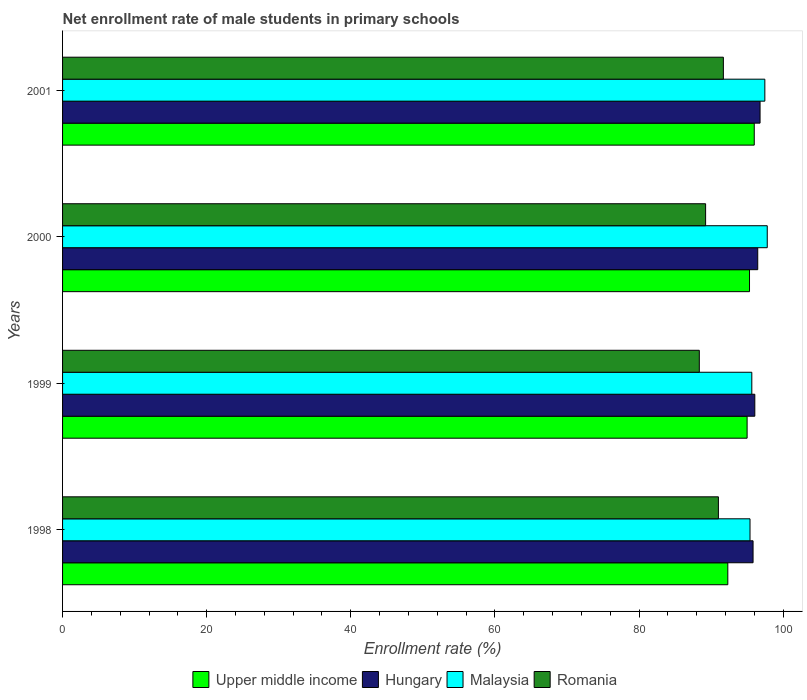How many different coloured bars are there?
Make the answer very short. 4. How many groups of bars are there?
Your response must be concise. 4. How many bars are there on the 1st tick from the top?
Your answer should be compact. 4. What is the net enrollment rate of male students in primary schools in Hungary in 1998?
Offer a very short reply. 95.83. Across all years, what is the maximum net enrollment rate of male students in primary schools in Romania?
Give a very brief answer. 91.71. Across all years, what is the minimum net enrollment rate of male students in primary schools in Upper middle income?
Make the answer very short. 92.32. In which year was the net enrollment rate of male students in primary schools in Hungary minimum?
Your answer should be very brief. 1998. What is the total net enrollment rate of male students in primary schools in Romania in the graph?
Make the answer very short. 360.34. What is the difference between the net enrollment rate of male students in primary schools in Romania in 2000 and that in 2001?
Offer a terse response. -2.47. What is the difference between the net enrollment rate of male students in primary schools in Romania in 2000 and the net enrollment rate of male students in primary schools in Hungary in 1999?
Your response must be concise. -6.83. What is the average net enrollment rate of male students in primary schools in Romania per year?
Give a very brief answer. 90.08. In the year 1999, what is the difference between the net enrollment rate of male students in primary schools in Upper middle income and net enrollment rate of male students in primary schools in Romania?
Your answer should be compact. 6.63. What is the ratio of the net enrollment rate of male students in primary schools in Hungary in 2000 to that in 2001?
Provide a succinct answer. 1. Is the net enrollment rate of male students in primary schools in Romania in 1998 less than that in 2000?
Provide a short and direct response. No. What is the difference between the highest and the second highest net enrollment rate of male students in primary schools in Romania?
Give a very brief answer. 0.69. What is the difference between the highest and the lowest net enrollment rate of male students in primary schools in Hungary?
Your response must be concise. 0.97. Is the sum of the net enrollment rate of male students in primary schools in Upper middle income in 2000 and 2001 greater than the maximum net enrollment rate of male students in primary schools in Hungary across all years?
Make the answer very short. Yes. Is it the case that in every year, the sum of the net enrollment rate of male students in primary schools in Malaysia and net enrollment rate of male students in primary schools in Hungary is greater than the sum of net enrollment rate of male students in primary schools in Romania and net enrollment rate of male students in primary schools in Upper middle income?
Provide a succinct answer. Yes. What does the 4th bar from the top in 1999 represents?
Offer a very short reply. Upper middle income. What does the 2nd bar from the bottom in 2000 represents?
Your answer should be very brief. Hungary. How many bars are there?
Provide a succinct answer. 16. Are all the bars in the graph horizontal?
Keep it short and to the point. Yes. What is the difference between two consecutive major ticks on the X-axis?
Give a very brief answer. 20. Are the values on the major ticks of X-axis written in scientific E-notation?
Offer a terse response. No. Does the graph contain grids?
Give a very brief answer. No. How many legend labels are there?
Keep it short and to the point. 4. How are the legend labels stacked?
Ensure brevity in your answer.  Horizontal. What is the title of the graph?
Offer a very short reply. Net enrollment rate of male students in primary schools. What is the label or title of the X-axis?
Give a very brief answer. Enrollment rate (%). What is the Enrollment rate (%) of Upper middle income in 1998?
Offer a terse response. 92.32. What is the Enrollment rate (%) in Hungary in 1998?
Provide a succinct answer. 95.83. What is the Enrollment rate (%) of Malaysia in 1998?
Your answer should be compact. 95.4. What is the Enrollment rate (%) in Romania in 1998?
Offer a very short reply. 91.02. What is the Enrollment rate (%) of Upper middle income in 1999?
Your response must be concise. 95. What is the Enrollment rate (%) in Hungary in 1999?
Give a very brief answer. 96.07. What is the Enrollment rate (%) of Malaysia in 1999?
Make the answer very short. 95.65. What is the Enrollment rate (%) in Romania in 1999?
Provide a succinct answer. 88.37. What is the Enrollment rate (%) of Upper middle income in 2000?
Offer a very short reply. 95.33. What is the Enrollment rate (%) of Hungary in 2000?
Offer a very short reply. 96.48. What is the Enrollment rate (%) of Malaysia in 2000?
Keep it short and to the point. 97.8. What is the Enrollment rate (%) of Romania in 2000?
Provide a short and direct response. 89.24. What is the Enrollment rate (%) in Upper middle income in 2001?
Your answer should be very brief. 95.99. What is the Enrollment rate (%) of Hungary in 2001?
Your answer should be very brief. 96.8. What is the Enrollment rate (%) of Malaysia in 2001?
Ensure brevity in your answer.  97.46. What is the Enrollment rate (%) in Romania in 2001?
Offer a terse response. 91.71. Across all years, what is the maximum Enrollment rate (%) in Upper middle income?
Your answer should be compact. 95.99. Across all years, what is the maximum Enrollment rate (%) in Hungary?
Keep it short and to the point. 96.8. Across all years, what is the maximum Enrollment rate (%) of Malaysia?
Provide a short and direct response. 97.8. Across all years, what is the maximum Enrollment rate (%) of Romania?
Your response must be concise. 91.71. Across all years, what is the minimum Enrollment rate (%) of Upper middle income?
Make the answer very short. 92.32. Across all years, what is the minimum Enrollment rate (%) of Hungary?
Keep it short and to the point. 95.83. Across all years, what is the minimum Enrollment rate (%) of Malaysia?
Your answer should be very brief. 95.4. Across all years, what is the minimum Enrollment rate (%) of Romania?
Ensure brevity in your answer.  88.37. What is the total Enrollment rate (%) of Upper middle income in the graph?
Your response must be concise. 378.65. What is the total Enrollment rate (%) in Hungary in the graph?
Give a very brief answer. 385.17. What is the total Enrollment rate (%) in Malaysia in the graph?
Your answer should be compact. 386.32. What is the total Enrollment rate (%) of Romania in the graph?
Offer a terse response. 360.34. What is the difference between the Enrollment rate (%) in Upper middle income in 1998 and that in 1999?
Offer a very short reply. -2.68. What is the difference between the Enrollment rate (%) of Hungary in 1998 and that in 1999?
Offer a very short reply. -0.24. What is the difference between the Enrollment rate (%) of Malaysia in 1998 and that in 1999?
Make the answer very short. -0.25. What is the difference between the Enrollment rate (%) of Romania in 1998 and that in 1999?
Offer a terse response. 2.65. What is the difference between the Enrollment rate (%) of Upper middle income in 1998 and that in 2000?
Keep it short and to the point. -3.01. What is the difference between the Enrollment rate (%) of Hungary in 1998 and that in 2000?
Give a very brief answer. -0.65. What is the difference between the Enrollment rate (%) in Malaysia in 1998 and that in 2000?
Provide a short and direct response. -2.39. What is the difference between the Enrollment rate (%) in Romania in 1998 and that in 2000?
Make the answer very short. 1.78. What is the difference between the Enrollment rate (%) in Upper middle income in 1998 and that in 2001?
Offer a terse response. -3.67. What is the difference between the Enrollment rate (%) in Hungary in 1998 and that in 2001?
Give a very brief answer. -0.97. What is the difference between the Enrollment rate (%) in Malaysia in 1998 and that in 2001?
Provide a short and direct response. -2.06. What is the difference between the Enrollment rate (%) in Romania in 1998 and that in 2001?
Your response must be concise. -0.69. What is the difference between the Enrollment rate (%) in Upper middle income in 1999 and that in 2000?
Ensure brevity in your answer.  -0.33. What is the difference between the Enrollment rate (%) in Hungary in 1999 and that in 2000?
Your response must be concise. -0.41. What is the difference between the Enrollment rate (%) of Malaysia in 1999 and that in 2000?
Provide a short and direct response. -2.14. What is the difference between the Enrollment rate (%) in Romania in 1999 and that in 2000?
Ensure brevity in your answer.  -0.88. What is the difference between the Enrollment rate (%) of Upper middle income in 1999 and that in 2001?
Your answer should be very brief. -0.99. What is the difference between the Enrollment rate (%) in Hungary in 1999 and that in 2001?
Make the answer very short. -0.73. What is the difference between the Enrollment rate (%) in Malaysia in 1999 and that in 2001?
Your answer should be very brief. -1.81. What is the difference between the Enrollment rate (%) of Romania in 1999 and that in 2001?
Your response must be concise. -3.34. What is the difference between the Enrollment rate (%) of Upper middle income in 2000 and that in 2001?
Make the answer very short. -0.66. What is the difference between the Enrollment rate (%) of Hungary in 2000 and that in 2001?
Offer a terse response. -0.32. What is the difference between the Enrollment rate (%) in Malaysia in 2000 and that in 2001?
Provide a succinct answer. 0.34. What is the difference between the Enrollment rate (%) in Romania in 2000 and that in 2001?
Give a very brief answer. -2.47. What is the difference between the Enrollment rate (%) in Upper middle income in 1998 and the Enrollment rate (%) in Hungary in 1999?
Ensure brevity in your answer.  -3.75. What is the difference between the Enrollment rate (%) in Upper middle income in 1998 and the Enrollment rate (%) in Malaysia in 1999?
Provide a succinct answer. -3.33. What is the difference between the Enrollment rate (%) of Upper middle income in 1998 and the Enrollment rate (%) of Romania in 1999?
Your answer should be compact. 3.95. What is the difference between the Enrollment rate (%) in Hungary in 1998 and the Enrollment rate (%) in Malaysia in 1999?
Provide a short and direct response. 0.17. What is the difference between the Enrollment rate (%) of Hungary in 1998 and the Enrollment rate (%) of Romania in 1999?
Provide a short and direct response. 7.46. What is the difference between the Enrollment rate (%) in Malaysia in 1998 and the Enrollment rate (%) in Romania in 1999?
Offer a very short reply. 7.04. What is the difference between the Enrollment rate (%) of Upper middle income in 1998 and the Enrollment rate (%) of Hungary in 2000?
Make the answer very short. -4.15. What is the difference between the Enrollment rate (%) of Upper middle income in 1998 and the Enrollment rate (%) of Malaysia in 2000?
Give a very brief answer. -5.47. What is the difference between the Enrollment rate (%) of Upper middle income in 1998 and the Enrollment rate (%) of Romania in 2000?
Give a very brief answer. 3.08. What is the difference between the Enrollment rate (%) in Hungary in 1998 and the Enrollment rate (%) in Malaysia in 2000?
Your answer should be compact. -1.97. What is the difference between the Enrollment rate (%) of Hungary in 1998 and the Enrollment rate (%) of Romania in 2000?
Offer a very short reply. 6.59. What is the difference between the Enrollment rate (%) of Malaysia in 1998 and the Enrollment rate (%) of Romania in 2000?
Provide a short and direct response. 6.16. What is the difference between the Enrollment rate (%) of Upper middle income in 1998 and the Enrollment rate (%) of Hungary in 2001?
Offer a terse response. -4.48. What is the difference between the Enrollment rate (%) of Upper middle income in 1998 and the Enrollment rate (%) of Malaysia in 2001?
Make the answer very short. -5.14. What is the difference between the Enrollment rate (%) of Upper middle income in 1998 and the Enrollment rate (%) of Romania in 2001?
Keep it short and to the point. 0.61. What is the difference between the Enrollment rate (%) in Hungary in 1998 and the Enrollment rate (%) in Malaysia in 2001?
Ensure brevity in your answer.  -1.63. What is the difference between the Enrollment rate (%) in Hungary in 1998 and the Enrollment rate (%) in Romania in 2001?
Offer a terse response. 4.12. What is the difference between the Enrollment rate (%) of Malaysia in 1998 and the Enrollment rate (%) of Romania in 2001?
Make the answer very short. 3.7. What is the difference between the Enrollment rate (%) of Upper middle income in 1999 and the Enrollment rate (%) of Hungary in 2000?
Make the answer very short. -1.47. What is the difference between the Enrollment rate (%) of Upper middle income in 1999 and the Enrollment rate (%) of Malaysia in 2000?
Give a very brief answer. -2.8. What is the difference between the Enrollment rate (%) in Upper middle income in 1999 and the Enrollment rate (%) in Romania in 2000?
Make the answer very short. 5.76. What is the difference between the Enrollment rate (%) of Hungary in 1999 and the Enrollment rate (%) of Malaysia in 2000?
Your answer should be compact. -1.73. What is the difference between the Enrollment rate (%) in Hungary in 1999 and the Enrollment rate (%) in Romania in 2000?
Offer a very short reply. 6.83. What is the difference between the Enrollment rate (%) of Malaysia in 1999 and the Enrollment rate (%) of Romania in 2000?
Ensure brevity in your answer.  6.41. What is the difference between the Enrollment rate (%) of Upper middle income in 1999 and the Enrollment rate (%) of Hungary in 2001?
Give a very brief answer. -1.8. What is the difference between the Enrollment rate (%) of Upper middle income in 1999 and the Enrollment rate (%) of Malaysia in 2001?
Provide a succinct answer. -2.46. What is the difference between the Enrollment rate (%) of Upper middle income in 1999 and the Enrollment rate (%) of Romania in 2001?
Provide a short and direct response. 3.29. What is the difference between the Enrollment rate (%) of Hungary in 1999 and the Enrollment rate (%) of Malaysia in 2001?
Offer a very short reply. -1.39. What is the difference between the Enrollment rate (%) in Hungary in 1999 and the Enrollment rate (%) in Romania in 2001?
Make the answer very short. 4.36. What is the difference between the Enrollment rate (%) of Malaysia in 1999 and the Enrollment rate (%) of Romania in 2001?
Offer a terse response. 3.95. What is the difference between the Enrollment rate (%) in Upper middle income in 2000 and the Enrollment rate (%) in Hungary in 2001?
Your answer should be compact. -1.46. What is the difference between the Enrollment rate (%) of Upper middle income in 2000 and the Enrollment rate (%) of Malaysia in 2001?
Your answer should be very brief. -2.13. What is the difference between the Enrollment rate (%) in Upper middle income in 2000 and the Enrollment rate (%) in Romania in 2001?
Offer a very short reply. 3.63. What is the difference between the Enrollment rate (%) of Hungary in 2000 and the Enrollment rate (%) of Malaysia in 2001?
Make the answer very short. -0.99. What is the difference between the Enrollment rate (%) of Hungary in 2000 and the Enrollment rate (%) of Romania in 2001?
Give a very brief answer. 4.77. What is the difference between the Enrollment rate (%) of Malaysia in 2000 and the Enrollment rate (%) of Romania in 2001?
Ensure brevity in your answer.  6.09. What is the average Enrollment rate (%) in Upper middle income per year?
Provide a short and direct response. 94.66. What is the average Enrollment rate (%) in Hungary per year?
Make the answer very short. 96.29. What is the average Enrollment rate (%) in Malaysia per year?
Provide a succinct answer. 96.58. What is the average Enrollment rate (%) of Romania per year?
Keep it short and to the point. 90.08. In the year 1998, what is the difference between the Enrollment rate (%) of Upper middle income and Enrollment rate (%) of Hungary?
Offer a very short reply. -3.51. In the year 1998, what is the difference between the Enrollment rate (%) in Upper middle income and Enrollment rate (%) in Malaysia?
Offer a terse response. -3.08. In the year 1998, what is the difference between the Enrollment rate (%) in Upper middle income and Enrollment rate (%) in Romania?
Your answer should be compact. 1.3. In the year 1998, what is the difference between the Enrollment rate (%) in Hungary and Enrollment rate (%) in Malaysia?
Provide a succinct answer. 0.42. In the year 1998, what is the difference between the Enrollment rate (%) in Hungary and Enrollment rate (%) in Romania?
Provide a short and direct response. 4.81. In the year 1998, what is the difference between the Enrollment rate (%) in Malaysia and Enrollment rate (%) in Romania?
Make the answer very short. 4.39. In the year 1999, what is the difference between the Enrollment rate (%) in Upper middle income and Enrollment rate (%) in Hungary?
Give a very brief answer. -1.07. In the year 1999, what is the difference between the Enrollment rate (%) in Upper middle income and Enrollment rate (%) in Malaysia?
Your answer should be compact. -0.65. In the year 1999, what is the difference between the Enrollment rate (%) in Upper middle income and Enrollment rate (%) in Romania?
Offer a terse response. 6.63. In the year 1999, what is the difference between the Enrollment rate (%) of Hungary and Enrollment rate (%) of Malaysia?
Provide a short and direct response. 0.41. In the year 1999, what is the difference between the Enrollment rate (%) in Hungary and Enrollment rate (%) in Romania?
Offer a very short reply. 7.7. In the year 1999, what is the difference between the Enrollment rate (%) of Malaysia and Enrollment rate (%) of Romania?
Give a very brief answer. 7.29. In the year 2000, what is the difference between the Enrollment rate (%) in Upper middle income and Enrollment rate (%) in Hungary?
Your answer should be very brief. -1.14. In the year 2000, what is the difference between the Enrollment rate (%) in Upper middle income and Enrollment rate (%) in Malaysia?
Give a very brief answer. -2.46. In the year 2000, what is the difference between the Enrollment rate (%) in Upper middle income and Enrollment rate (%) in Romania?
Ensure brevity in your answer.  6.09. In the year 2000, what is the difference between the Enrollment rate (%) of Hungary and Enrollment rate (%) of Malaysia?
Offer a terse response. -1.32. In the year 2000, what is the difference between the Enrollment rate (%) of Hungary and Enrollment rate (%) of Romania?
Keep it short and to the point. 7.23. In the year 2000, what is the difference between the Enrollment rate (%) of Malaysia and Enrollment rate (%) of Romania?
Provide a succinct answer. 8.55. In the year 2001, what is the difference between the Enrollment rate (%) of Upper middle income and Enrollment rate (%) of Hungary?
Ensure brevity in your answer.  -0.81. In the year 2001, what is the difference between the Enrollment rate (%) in Upper middle income and Enrollment rate (%) in Malaysia?
Give a very brief answer. -1.47. In the year 2001, what is the difference between the Enrollment rate (%) in Upper middle income and Enrollment rate (%) in Romania?
Your response must be concise. 4.28. In the year 2001, what is the difference between the Enrollment rate (%) in Hungary and Enrollment rate (%) in Malaysia?
Your answer should be compact. -0.66. In the year 2001, what is the difference between the Enrollment rate (%) of Hungary and Enrollment rate (%) of Romania?
Provide a short and direct response. 5.09. In the year 2001, what is the difference between the Enrollment rate (%) in Malaysia and Enrollment rate (%) in Romania?
Your answer should be very brief. 5.75. What is the ratio of the Enrollment rate (%) of Upper middle income in 1998 to that in 1999?
Offer a very short reply. 0.97. What is the ratio of the Enrollment rate (%) in Hungary in 1998 to that in 1999?
Ensure brevity in your answer.  1. What is the ratio of the Enrollment rate (%) in Malaysia in 1998 to that in 1999?
Provide a short and direct response. 1. What is the ratio of the Enrollment rate (%) in Upper middle income in 1998 to that in 2000?
Give a very brief answer. 0.97. What is the ratio of the Enrollment rate (%) in Hungary in 1998 to that in 2000?
Keep it short and to the point. 0.99. What is the ratio of the Enrollment rate (%) in Malaysia in 1998 to that in 2000?
Keep it short and to the point. 0.98. What is the ratio of the Enrollment rate (%) in Romania in 1998 to that in 2000?
Offer a terse response. 1.02. What is the ratio of the Enrollment rate (%) in Upper middle income in 1998 to that in 2001?
Your answer should be compact. 0.96. What is the ratio of the Enrollment rate (%) of Hungary in 1998 to that in 2001?
Make the answer very short. 0.99. What is the ratio of the Enrollment rate (%) of Malaysia in 1998 to that in 2001?
Keep it short and to the point. 0.98. What is the ratio of the Enrollment rate (%) in Malaysia in 1999 to that in 2000?
Give a very brief answer. 0.98. What is the ratio of the Enrollment rate (%) of Romania in 1999 to that in 2000?
Keep it short and to the point. 0.99. What is the ratio of the Enrollment rate (%) in Upper middle income in 1999 to that in 2001?
Your response must be concise. 0.99. What is the ratio of the Enrollment rate (%) of Malaysia in 1999 to that in 2001?
Your answer should be very brief. 0.98. What is the ratio of the Enrollment rate (%) of Romania in 1999 to that in 2001?
Your answer should be very brief. 0.96. What is the ratio of the Enrollment rate (%) in Upper middle income in 2000 to that in 2001?
Ensure brevity in your answer.  0.99. What is the ratio of the Enrollment rate (%) in Hungary in 2000 to that in 2001?
Offer a very short reply. 1. What is the ratio of the Enrollment rate (%) of Romania in 2000 to that in 2001?
Provide a succinct answer. 0.97. What is the difference between the highest and the second highest Enrollment rate (%) of Upper middle income?
Give a very brief answer. 0.66. What is the difference between the highest and the second highest Enrollment rate (%) of Hungary?
Your response must be concise. 0.32. What is the difference between the highest and the second highest Enrollment rate (%) in Malaysia?
Offer a terse response. 0.34. What is the difference between the highest and the second highest Enrollment rate (%) of Romania?
Make the answer very short. 0.69. What is the difference between the highest and the lowest Enrollment rate (%) of Upper middle income?
Offer a very short reply. 3.67. What is the difference between the highest and the lowest Enrollment rate (%) in Hungary?
Make the answer very short. 0.97. What is the difference between the highest and the lowest Enrollment rate (%) in Malaysia?
Give a very brief answer. 2.39. What is the difference between the highest and the lowest Enrollment rate (%) in Romania?
Make the answer very short. 3.34. 